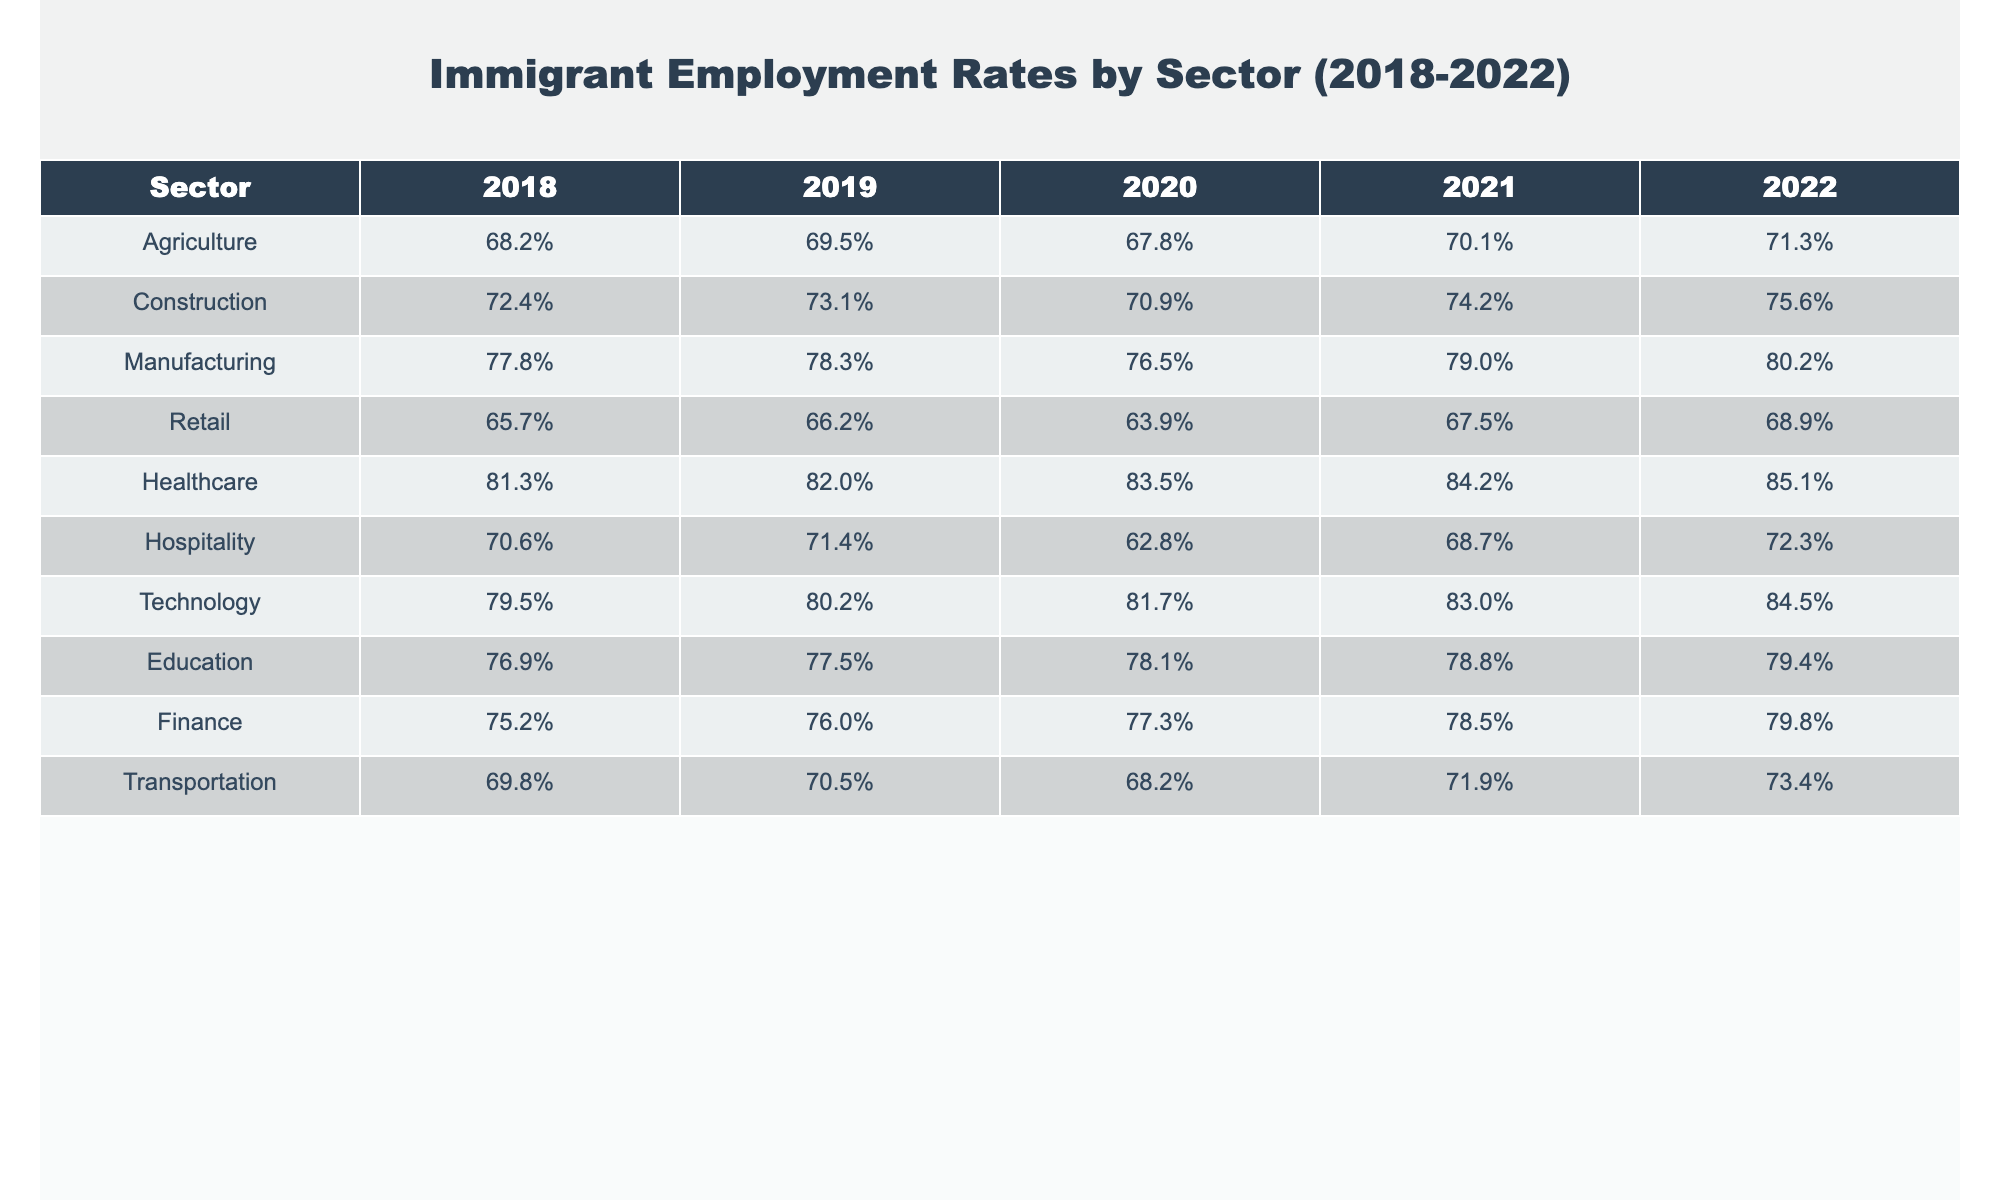What was the employment rate of immigrants in the healthcare sector in 2022? The table shows that the employment rate for immigrants in the healthcare sector for 2022 is 85.1%.
Answer: 85.1% Which sector had the highest employment rate for immigrants in 2021? By comparing the employment rates across the sectors in 2021, the healthcare sector had the highest rate at 84.2%.
Answer: Healthcare What is the difference in the employment rate for immigrants in the construction sector between 2018 and 2022? The employment rate in the construction sector for 2018 was 72.4% and for 2022 was 75.6%. The difference is 75.6% - 72.4% = 3.2%.
Answer: 3.2% What was the average employment rate for immigrants in the manufacturing sector over the five years? The rates for manufacturing from 2018 to 2022 are 77.8%, 78.3%, 76.5%, 79.0%, and 80.2%. To find the average, sum these values (77.8 + 78.3 + 76.5 + 79.0 + 80.2 = 391.8) and divide by 5, which gives 391.8 / 5 = 78.36%.
Answer: 78.36% In which sector did the employment rate for immigrants decline in 2020 compared to 2019? By checking the rates, we can see that the hospitality sector dropped from 71.4% in 2019 to 62.8% in 2020, indicating a decline.
Answer: Hospitality Was the immigrant employment rate in the retail sector higher in 2021 than in 2018? The retail sector had an employment rate of 67.5% in 2021, compared to 65.7% in 2018, which confirms that it was higher in 2021.
Answer: Yes Which sector experienced the largest increase in immigrant employment rate from 2018 to 2022? By examining the rates, healthcare increased from 81.3% in 2018 to 85.1% in 2022, amounting to an increase of 3.8%. No other sector shows a larger increase, making healthcare the largest.
Answer: Healthcare What was the immigrant employment rate in the technology sector in 2019, and how does it compare to the retail sector in the same year? The technology sector had an employment rate of 80.2% in 2019, while the retail sector was at 66.2%. Comparing these, technology has a significantly higher rate than retail, showing a difference of 80.2% - 66.2% = 14%.
Answer: Technology is higher by 14% In which year did the transportation sector show its lowest employment rate for immigrants? By checking the transportation rates from all the years, we see that the lowest rate was 68.2% in 2020.
Answer: 2020 What is the trend of the agricultural sector's employment rate over the last five years? The agricultural sector's rates increased from 68.2% in 2018 to 71.3% in 2022, showing a consistent upward trend.
Answer: Upward trend 